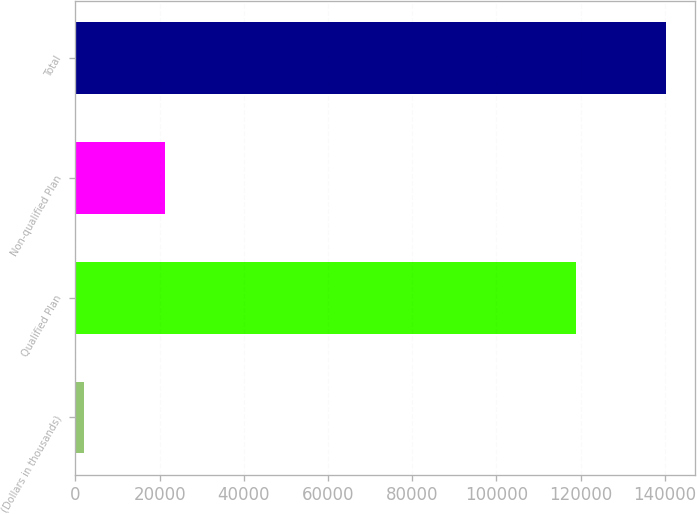Convert chart to OTSL. <chart><loc_0><loc_0><loc_500><loc_500><bar_chart><fcel>(Dollars in thousands)<fcel>Qualified Plan<fcel>Non-qualified Plan<fcel>Total<nl><fcel>2011<fcel>118981<fcel>21231<fcel>140212<nl></chart> 